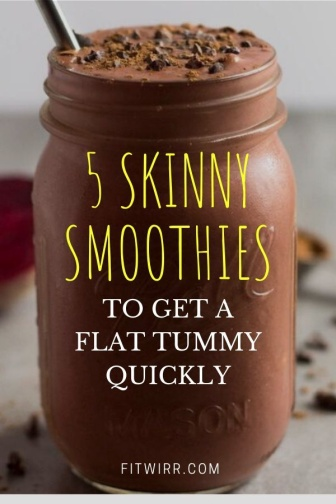Explain the visual content of the image in great detail. The image features a detailed and appealing scene centered around a chocolate-flavored smoothie served in a vintage-style mason jar. The jar, almost completely filled with this thick and creamy beverage, also contains a metal straw indicating its ready-to-drink nature. The composition is further enriched with visually scattered chocolate chips on the gray countertop which introduces a textural contrast as well as hints at the smoothie's flavor. The background is simple, emphasizing the subject. Overlaying the image is vibrant, yellow text that offers a weight management promise with '5 SKINNY SMOOTHIES TO GET A FLAT TUMMY QUICKLY', highlighted further by the boldness and larger font of 'SKINNY'. The mention of 'fitwirr.com' suggests a source and credibly ties the image to a health and fitness context. The overall presentation uses appetite appeal combined with a health-oriented message to attract viewers' interest in the recipes. 